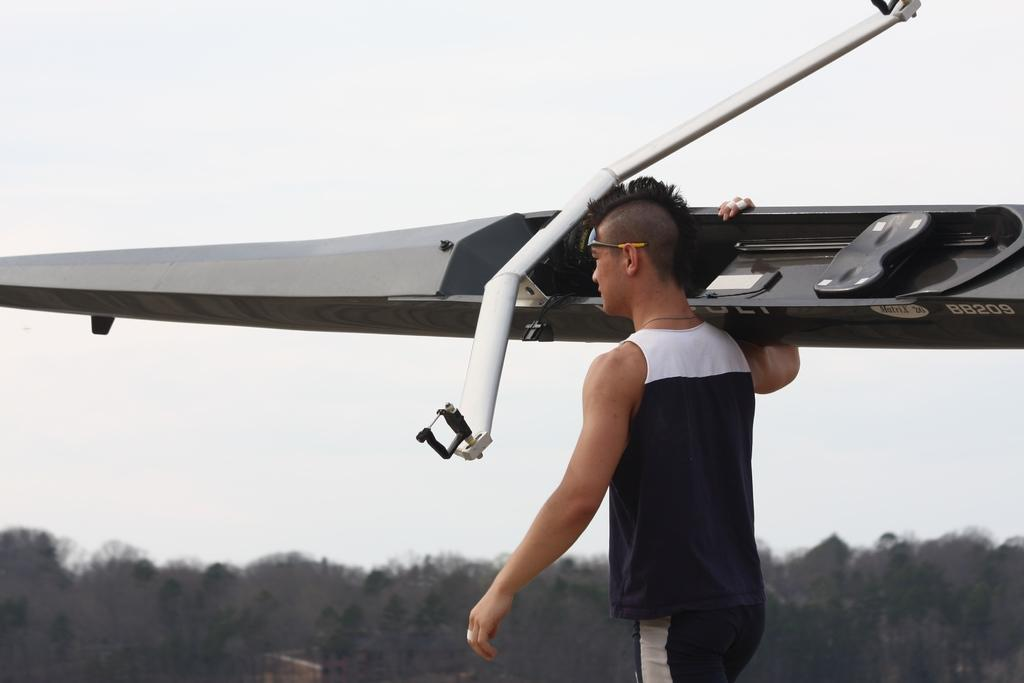<image>
Render a clear and concise summary of the photo. The canoe has white letters and numbers of BB209. 